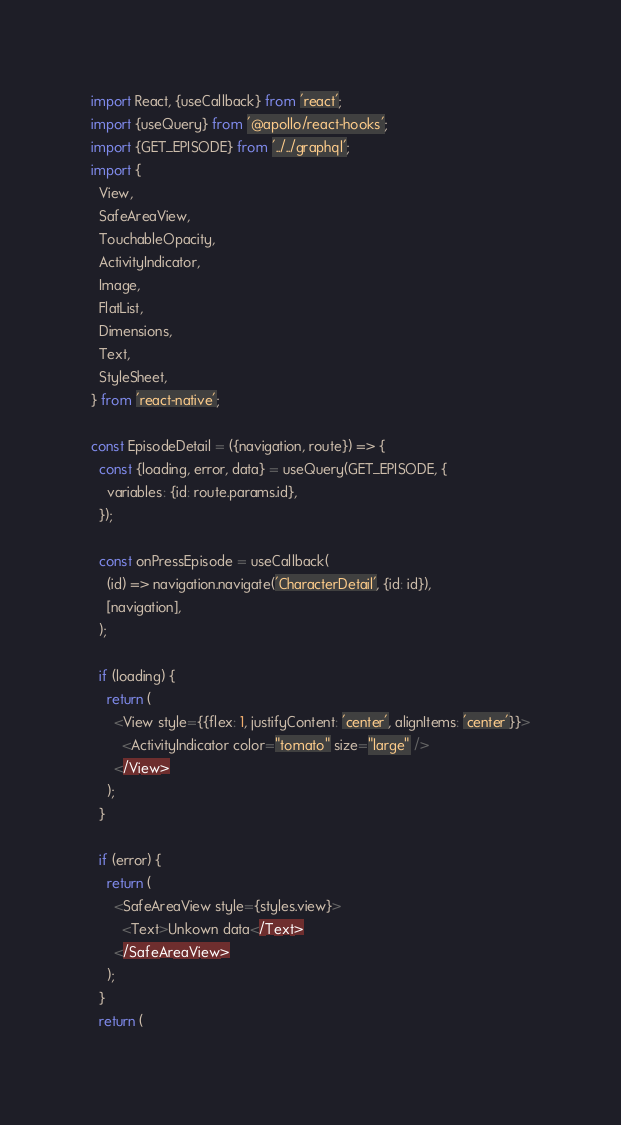Convert code to text. <code><loc_0><loc_0><loc_500><loc_500><_JavaScript_>import React, {useCallback} from 'react';
import {useQuery} from '@apollo/react-hooks';
import {GET_EPISODE} from '../../graphql';
import {
  View,
  SafeAreaView,
  TouchableOpacity,
  ActivityIndicator,
  Image,
  FlatList,
  Dimensions,
  Text,
  StyleSheet,
} from 'react-native';

const EpisodeDetail = ({navigation, route}) => {
  const {loading, error, data} = useQuery(GET_EPISODE, {
    variables: {id: route.params.id},
  });

  const onPressEpisode = useCallback(
    (id) => navigation.navigate('CharacterDetail', {id: id}),
    [navigation],
  );

  if (loading) {
    return (
      <View style={{flex: 1, justifyContent: 'center', alignItems: 'center'}}>
        <ActivityIndicator color="tomato" size="large" />
      </View>
    );
  }

  if (error) {
    return (
      <SafeAreaView style={styles.view}>
        <Text>Unkown data</Text>
      </SafeAreaView>
    );
  }
  return (</code> 